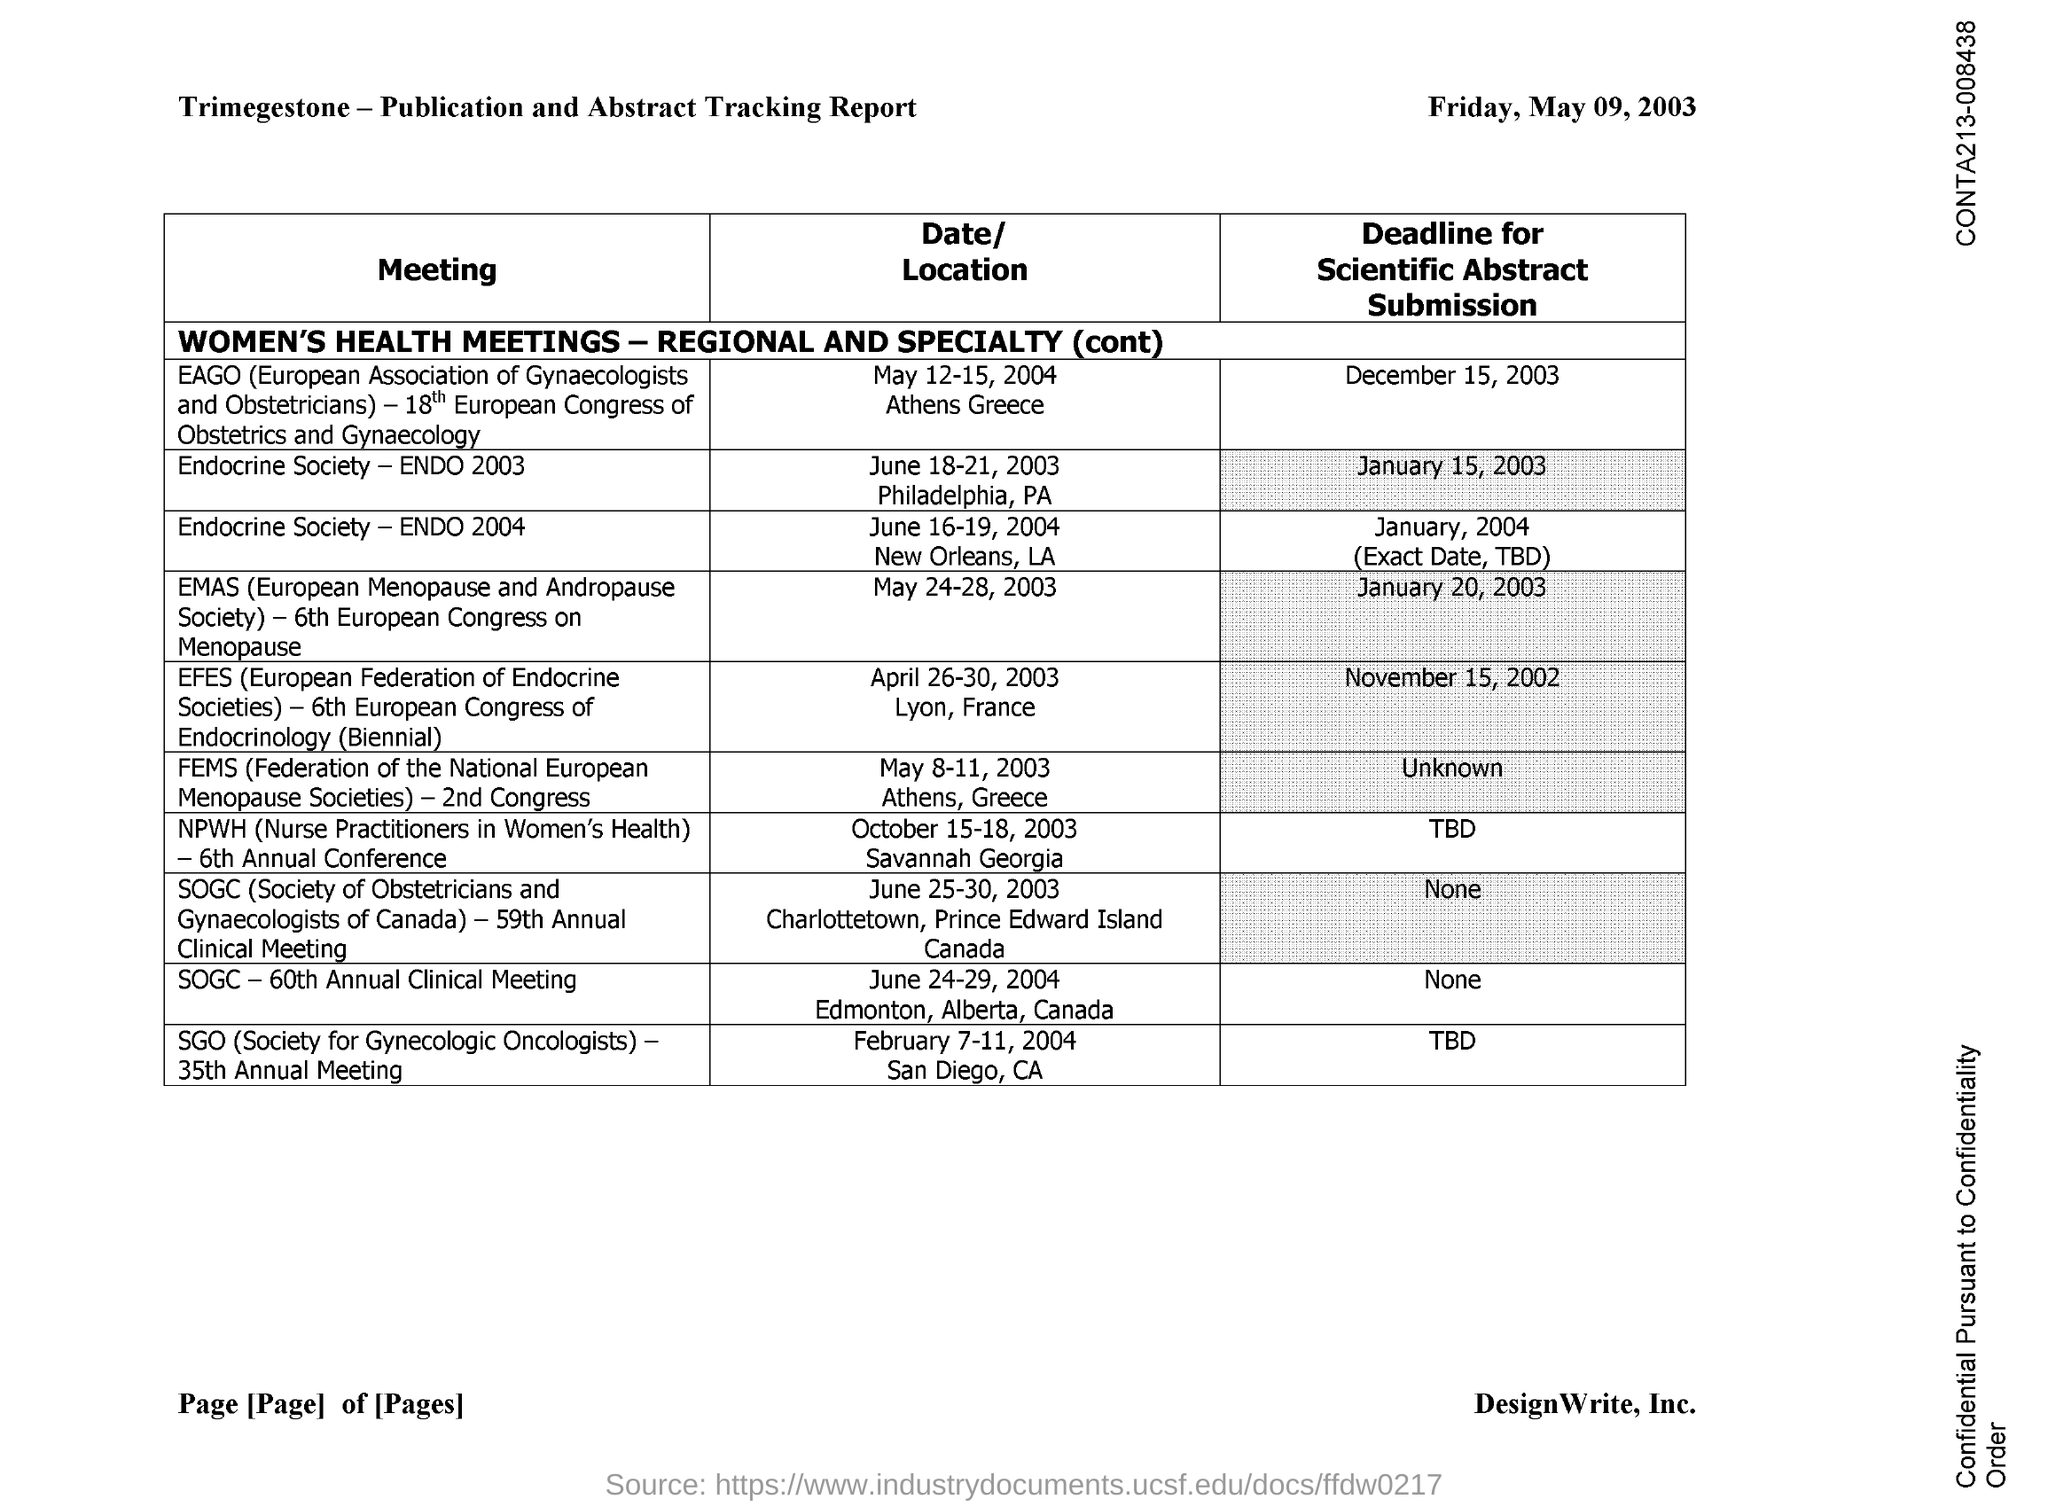What is the full form of SOGC?
Provide a short and direct response. Society of obstetricians and gynaecologists of canada. 